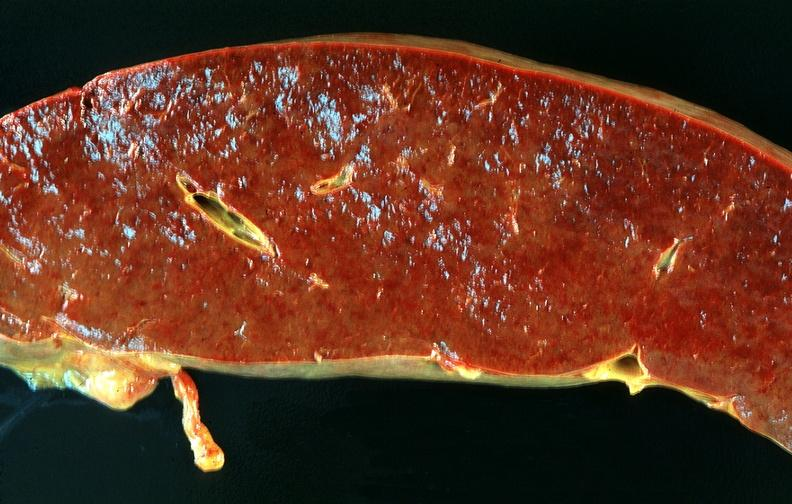s hemochromatosis present?
Answer the question using a single word or phrase. No 